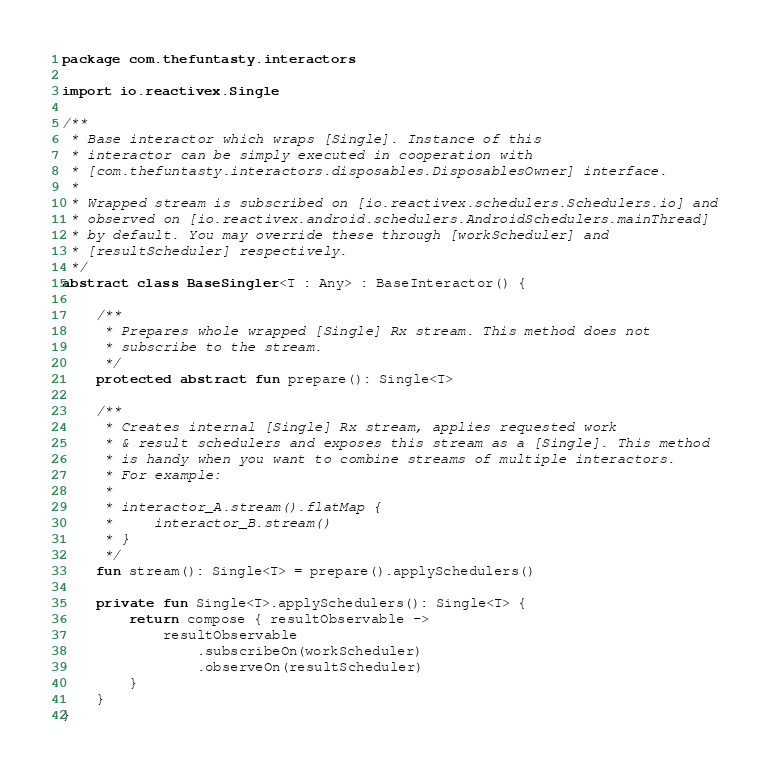Convert code to text. <code><loc_0><loc_0><loc_500><loc_500><_Kotlin_>package com.thefuntasty.interactors

import io.reactivex.Single

/**
 * Base interactor which wraps [Single]. Instance of this
 * interactor can be simply executed in cooperation with
 * [com.thefuntasty.interactors.disposables.DisposablesOwner] interface.
 *
 * Wrapped stream is subscribed on [io.reactivex.schedulers.Schedulers.io] and
 * observed on [io.reactivex.android.schedulers.AndroidSchedulers.mainThread]
 * by default. You may override these through [workScheduler] and
 * [resultScheduler] respectively.
 */
abstract class BaseSingler<T : Any> : BaseInteractor() {

    /**
     * Prepares whole wrapped [Single] Rx stream. This method does not
     * subscribe to the stream.
     */
    protected abstract fun prepare(): Single<T>

    /**
     * Creates internal [Single] Rx stream, applies requested work
     * & result schedulers and exposes this stream as a [Single]. This method
     * is handy when you want to combine streams of multiple interactors.
     * For example:
     *
     * interactor_A.stream().flatMap {
     *     interactor_B.stream()
     * }
     */
    fun stream(): Single<T> = prepare().applySchedulers()

    private fun Single<T>.applySchedulers(): Single<T> {
        return compose { resultObservable ->
            resultObservable
                .subscribeOn(workScheduler)
                .observeOn(resultScheduler)
        }
    }
}
</code> 